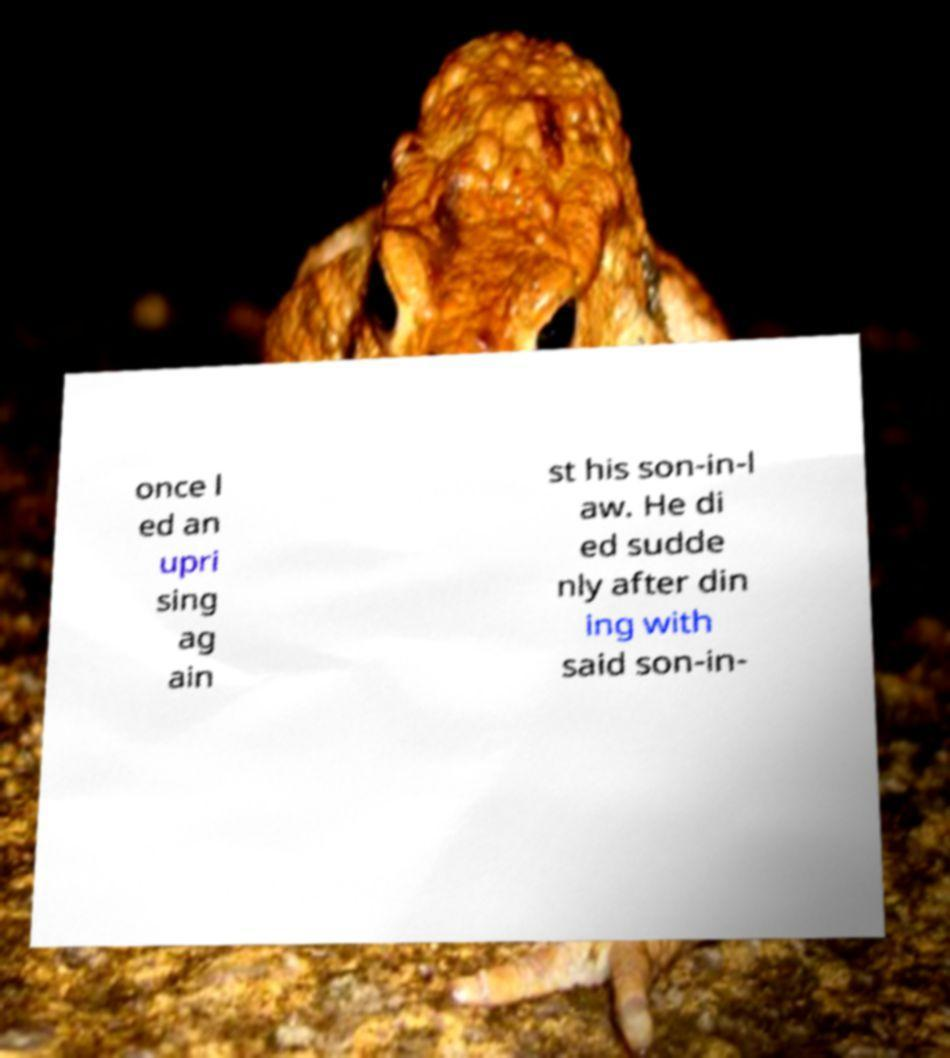Can you read and provide the text displayed in the image?This photo seems to have some interesting text. Can you extract and type it out for me? once l ed an upri sing ag ain st his son-in-l aw. He di ed sudde nly after din ing with said son-in- 